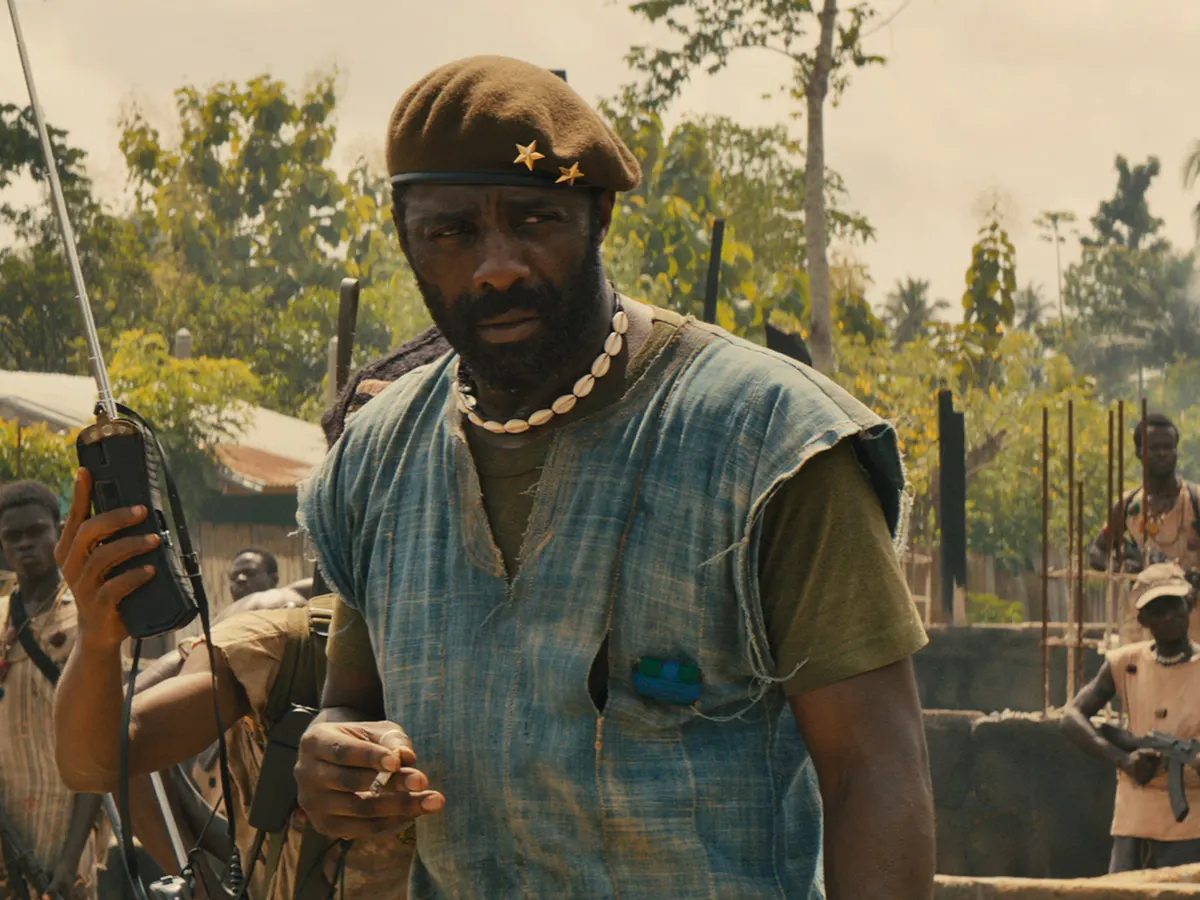Can you elaborate on the elements of the picture provided? In the image, we see an actor who resembles Idris Elba, likely in his role as Commandant from the movie 'Beasts of No Nation.' He stands in a dusty, war-torn village, appearing authoritative as he gives commands. He is dressed in a blue sleeveless shirt with a green vest over it and a green beret adorned with two gold stars. He wears a necklace made of white beads. In his right hand, he holds a walkie-talkie, looking alert, and a gun is slung over his left shoulder. The background is composed of his followers, presumably soldiers, who listen intently to his directives. Surrounding them is a landscape marked by dilapidation and a sense of ongoing conflict, with makeshift structures and sparse vegetation adding to the atmosphere of turmoil. 